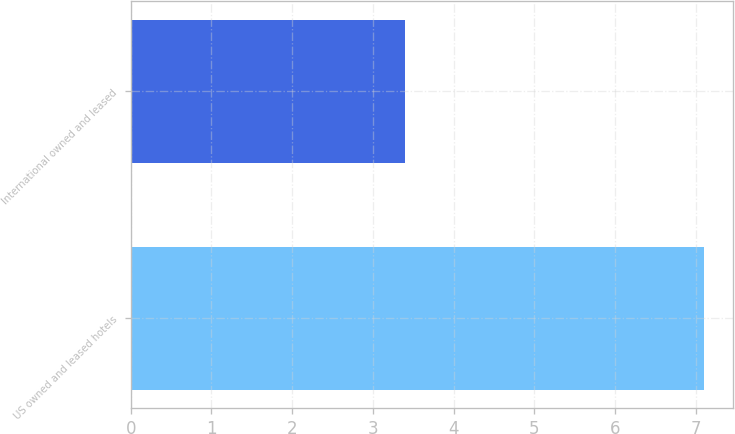<chart> <loc_0><loc_0><loc_500><loc_500><bar_chart><fcel>US owned and leased hotels<fcel>International owned and leased<nl><fcel>7.1<fcel>3.4<nl></chart> 